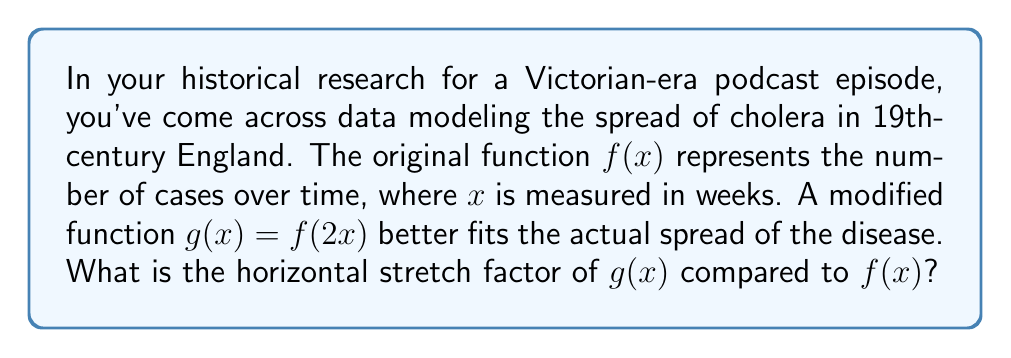Can you solve this math problem? To determine the horizontal stretch factor, we need to analyze the relationship between $f(x)$ and $g(x)$.

1) The given relationship is $g(x) = f(2x)$

2) In general, for a function $h(x) = f(ax)$, where $a > 0$:
   - If $a > 1$, it represents a horizontal compression by a factor of $a$
   - If $0 < a < 1$, it represents a horizontal stretch by a factor of $\frac{1}{a}$

3) In our case, $a = 2$, which is greater than 1

4) Therefore, $g(x) = f(2x)$ represents a horizontal compression of $f(x)$

5) The compression factor is 2

6) To find the stretch factor, we take the reciprocal of the compression factor:

   Stretch factor = $\frac{1}{\text{compression factor}} = \frac{1}{2}$

This means that $g(x)$ is a horizontally stretched version of $f(x)$ by a factor of $\frac{1}{2}$.
Answer: The horizontal stretch factor is $\frac{1}{2}$. 